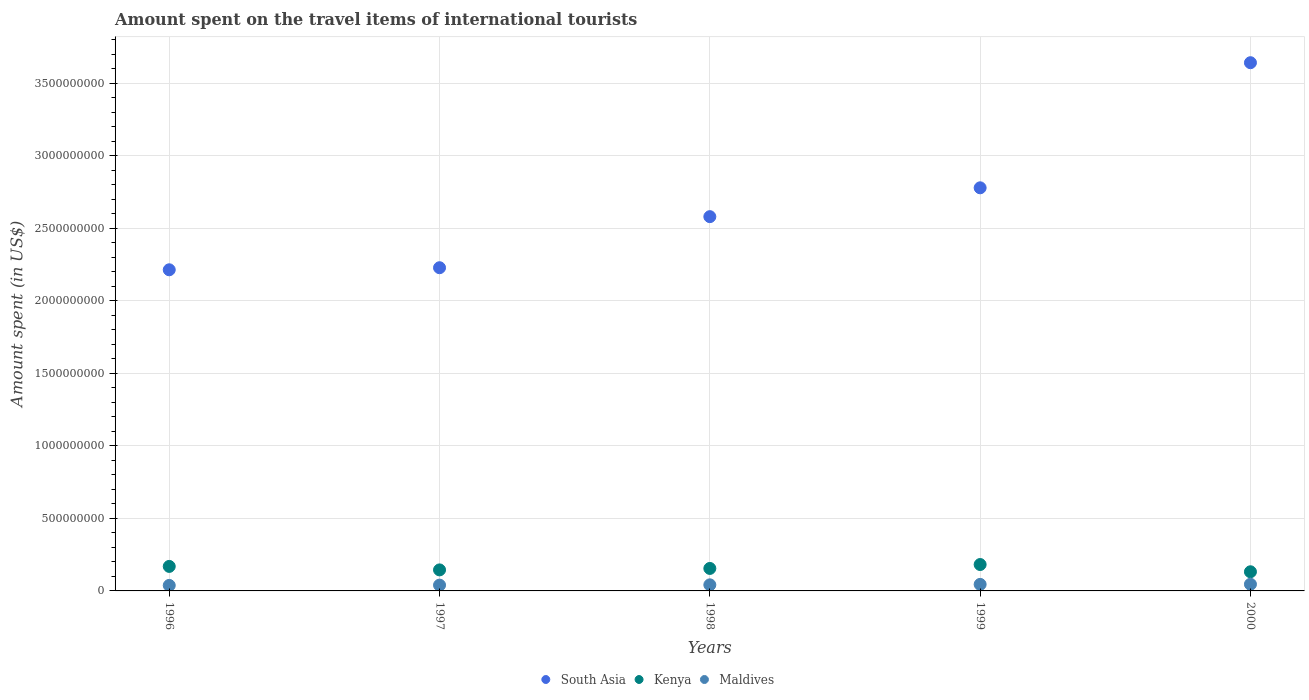What is the amount spent on the travel items of international tourists in South Asia in 1996?
Provide a short and direct response. 2.21e+09. Across all years, what is the maximum amount spent on the travel items of international tourists in Maldives?
Offer a very short reply. 4.60e+07. Across all years, what is the minimum amount spent on the travel items of international tourists in Maldives?
Keep it short and to the point. 3.80e+07. In which year was the amount spent on the travel items of international tourists in Kenya minimum?
Offer a very short reply. 2000. What is the total amount spent on the travel items of international tourists in Kenya in the graph?
Provide a short and direct response. 7.83e+08. What is the difference between the amount spent on the travel items of international tourists in Kenya in 1996 and that in 1997?
Give a very brief answer. 2.40e+07. What is the difference between the amount spent on the travel items of international tourists in South Asia in 1999 and the amount spent on the travel items of international tourists in Kenya in 1996?
Offer a very short reply. 2.61e+09. What is the average amount spent on the travel items of international tourists in Kenya per year?
Provide a short and direct response. 1.57e+08. In the year 2000, what is the difference between the amount spent on the travel items of international tourists in Maldives and amount spent on the travel items of international tourists in Kenya?
Provide a succinct answer. -8.60e+07. In how many years, is the amount spent on the travel items of international tourists in Maldives greater than 3100000000 US$?
Your answer should be very brief. 0. What is the ratio of the amount spent on the travel items of international tourists in South Asia in 1996 to that in 1999?
Your response must be concise. 0.8. Is the difference between the amount spent on the travel items of international tourists in Maldives in 1997 and 2000 greater than the difference between the amount spent on the travel items of international tourists in Kenya in 1997 and 2000?
Provide a succinct answer. No. In how many years, is the amount spent on the travel items of international tourists in Kenya greater than the average amount spent on the travel items of international tourists in Kenya taken over all years?
Offer a very short reply. 2. Is the sum of the amount spent on the travel items of international tourists in Kenya in 1996 and 2000 greater than the maximum amount spent on the travel items of international tourists in South Asia across all years?
Your response must be concise. No. Is the amount spent on the travel items of international tourists in Kenya strictly greater than the amount spent on the travel items of international tourists in Maldives over the years?
Your answer should be compact. Yes. Is the amount spent on the travel items of international tourists in Kenya strictly less than the amount spent on the travel items of international tourists in Maldives over the years?
Provide a short and direct response. No. How many dotlines are there?
Make the answer very short. 3. Are the values on the major ticks of Y-axis written in scientific E-notation?
Ensure brevity in your answer.  No. Does the graph contain any zero values?
Your response must be concise. No. Does the graph contain grids?
Give a very brief answer. Yes. How many legend labels are there?
Give a very brief answer. 3. How are the legend labels stacked?
Your answer should be very brief. Horizontal. What is the title of the graph?
Keep it short and to the point. Amount spent on the travel items of international tourists. Does "Malaysia" appear as one of the legend labels in the graph?
Offer a terse response. No. What is the label or title of the X-axis?
Your answer should be very brief. Years. What is the label or title of the Y-axis?
Your response must be concise. Amount spent (in US$). What is the Amount spent (in US$) of South Asia in 1996?
Offer a terse response. 2.21e+09. What is the Amount spent (in US$) in Kenya in 1996?
Ensure brevity in your answer.  1.69e+08. What is the Amount spent (in US$) of Maldives in 1996?
Give a very brief answer. 3.80e+07. What is the Amount spent (in US$) in South Asia in 1997?
Your answer should be compact. 2.23e+09. What is the Amount spent (in US$) of Kenya in 1997?
Your answer should be compact. 1.45e+08. What is the Amount spent (in US$) of Maldives in 1997?
Provide a succinct answer. 4.00e+07. What is the Amount spent (in US$) in South Asia in 1998?
Provide a short and direct response. 2.58e+09. What is the Amount spent (in US$) in Kenya in 1998?
Your response must be concise. 1.55e+08. What is the Amount spent (in US$) in Maldives in 1998?
Provide a succinct answer. 4.20e+07. What is the Amount spent (in US$) in South Asia in 1999?
Keep it short and to the point. 2.78e+09. What is the Amount spent (in US$) of Kenya in 1999?
Your answer should be compact. 1.82e+08. What is the Amount spent (in US$) in Maldives in 1999?
Your answer should be very brief. 4.50e+07. What is the Amount spent (in US$) of South Asia in 2000?
Your answer should be compact. 3.64e+09. What is the Amount spent (in US$) in Kenya in 2000?
Make the answer very short. 1.32e+08. What is the Amount spent (in US$) of Maldives in 2000?
Provide a short and direct response. 4.60e+07. Across all years, what is the maximum Amount spent (in US$) of South Asia?
Offer a very short reply. 3.64e+09. Across all years, what is the maximum Amount spent (in US$) in Kenya?
Provide a short and direct response. 1.82e+08. Across all years, what is the maximum Amount spent (in US$) of Maldives?
Your answer should be compact. 4.60e+07. Across all years, what is the minimum Amount spent (in US$) in South Asia?
Your answer should be very brief. 2.21e+09. Across all years, what is the minimum Amount spent (in US$) in Kenya?
Ensure brevity in your answer.  1.32e+08. Across all years, what is the minimum Amount spent (in US$) in Maldives?
Make the answer very short. 3.80e+07. What is the total Amount spent (in US$) in South Asia in the graph?
Provide a short and direct response. 1.34e+1. What is the total Amount spent (in US$) of Kenya in the graph?
Your answer should be very brief. 7.83e+08. What is the total Amount spent (in US$) of Maldives in the graph?
Your response must be concise. 2.11e+08. What is the difference between the Amount spent (in US$) of South Asia in 1996 and that in 1997?
Ensure brevity in your answer.  -1.42e+07. What is the difference between the Amount spent (in US$) in Kenya in 1996 and that in 1997?
Make the answer very short. 2.40e+07. What is the difference between the Amount spent (in US$) in Maldives in 1996 and that in 1997?
Give a very brief answer. -2.00e+06. What is the difference between the Amount spent (in US$) in South Asia in 1996 and that in 1998?
Ensure brevity in your answer.  -3.66e+08. What is the difference between the Amount spent (in US$) in Kenya in 1996 and that in 1998?
Your answer should be compact. 1.40e+07. What is the difference between the Amount spent (in US$) of Maldives in 1996 and that in 1998?
Ensure brevity in your answer.  -4.00e+06. What is the difference between the Amount spent (in US$) of South Asia in 1996 and that in 1999?
Ensure brevity in your answer.  -5.65e+08. What is the difference between the Amount spent (in US$) of Kenya in 1996 and that in 1999?
Make the answer very short. -1.30e+07. What is the difference between the Amount spent (in US$) in Maldives in 1996 and that in 1999?
Make the answer very short. -7.00e+06. What is the difference between the Amount spent (in US$) in South Asia in 1996 and that in 2000?
Keep it short and to the point. -1.43e+09. What is the difference between the Amount spent (in US$) of Kenya in 1996 and that in 2000?
Offer a terse response. 3.70e+07. What is the difference between the Amount spent (in US$) of Maldives in 1996 and that in 2000?
Provide a succinct answer. -8.00e+06. What is the difference between the Amount spent (in US$) of South Asia in 1997 and that in 1998?
Offer a terse response. -3.52e+08. What is the difference between the Amount spent (in US$) in Kenya in 1997 and that in 1998?
Keep it short and to the point. -1.00e+07. What is the difference between the Amount spent (in US$) in South Asia in 1997 and that in 1999?
Offer a terse response. -5.51e+08. What is the difference between the Amount spent (in US$) in Kenya in 1997 and that in 1999?
Your response must be concise. -3.70e+07. What is the difference between the Amount spent (in US$) of Maldives in 1997 and that in 1999?
Offer a very short reply. -5.00e+06. What is the difference between the Amount spent (in US$) of South Asia in 1997 and that in 2000?
Make the answer very short. -1.41e+09. What is the difference between the Amount spent (in US$) of Kenya in 1997 and that in 2000?
Offer a very short reply. 1.30e+07. What is the difference between the Amount spent (in US$) of Maldives in 1997 and that in 2000?
Offer a very short reply. -6.00e+06. What is the difference between the Amount spent (in US$) in South Asia in 1998 and that in 1999?
Your answer should be compact. -1.99e+08. What is the difference between the Amount spent (in US$) in Kenya in 1998 and that in 1999?
Provide a succinct answer. -2.70e+07. What is the difference between the Amount spent (in US$) of Maldives in 1998 and that in 1999?
Your response must be concise. -3.00e+06. What is the difference between the Amount spent (in US$) of South Asia in 1998 and that in 2000?
Provide a succinct answer. -1.06e+09. What is the difference between the Amount spent (in US$) in Kenya in 1998 and that in 2000?
Your response must be concise. 2.30e+07. What is the difference between the Amount spent (in US$) in Maldives in 1998 and that in 2000?
Your answer should be very brief. -4.00e+06. What is the difference between the Amount spent (in US$) in South Asia in 1999 and that in 2000?
Provide a short and direct response. -8.63e+08. What is the difference between the Amount spent (in US$) of Maldives in 1999 and that in 2000?
Provide a short and direct response. -1.00e+06. What is the difference between the Amount spent (in US$) of South Asia in 1996 and the Amount spent (in US$) of Kenya in 1997?
Your response must be concise. 2.07e+09. What is the difference between the Amount spent (in US$) in South Asia in 1996 and the Amount spent (in US$) in Maldives in 1997?
Provide a succinct answer. 2.17e+09. What is the difference between the Amount spent (in US$) in Kenya in 1996 and the Amount spent (in US$) in Maldives in 1997?
Ensure brevity in your answer.  1.29e+08. What is the difference between the Amount spent (in US$) of South Asia in 1996 and the Amount spent (in US$) of Kenya in 1998?
Give a very brief answer. 2.06e+09. What is the difference between the Amount spent (in US$) of South Asia in 1996 and the Amount spent (in US$) of Maldives in 1998?
Give a very brief answer. 2.17e+09. What is the difference between the Amount spent (in US$) in Kenya in 1996 and the Amount spent (in US$) in Maldives in 1998?
Make the answer very short. 1.27e+08. What is the difference between the Amount spent (in US$) in South Asia in 1996 and the Amount spent (in US$) in Kenya in 1999?
Your answer should be compact. 2.03e+09. What is the difference between the Amount spent (in US$) of South Asia in 1996 and the Amount spent (in US$) of Maldives in 1999?
Provide a short and direct response. 2.17e+09. What is the difference between the Amount spent (in US$) of Kenya in 1996 and the Amount spent (in US$) of Maldives in 1999?
Your answer should be compact. 1.24e+08. What is the difference between the Amount spent (in US$) of South Asia in 1996 and the Amount spent (in US$) of Kenya in 2000?
Give a very brief answer. 2.08e+09. What is the difference between the Amount spent (in US$) of South Asia in 1996 and the Amount spent (in US$) of Maldives in 2000?
Your answer should be very brief. 2.17e+09. What is the difference between the Amount spent (in US$) of Kenya in 1996 and the Amount spent (in US$) of Maldives in 2000?
Provide a succinct answer. 1.23e+08. What is the difference between the Amount spent (in US$) of South Asia in 1997 and the Amount spent (in US$) of Kenya in 1998?
Your answer should be very brief. 2.07e+09. What is the difference between the Amount spent (in US$) of South Asia in 1997 and the Amount spent (in US$) of Maldives in 1998?
Offer a very short reply. 2.19e+09. What is the difference between the Amount spent (in US$) of Kenya in 1997 and the Amount spent (in US$) of Maldives in 1998?
Provide a short and direct response. 1.03e+08. What is the difference between the Amount spent (in US$) in South Asia in 1997 and the Amount spent (in US$) in Kenya in 1999?
Ensure brevity in your answer.  2.05e+09. What is the difference between the Amount spent (in US$) of South Asia in 1997 and the Amount spent (in US$) of Maldives in 1999?
Your answer should be very brief. 2.18e+09. What is the difference between the Amount spent (in US$) of South Asia in 1997 and the Amount spent (in US$) of Kenya in 2000?
Provide a short and direct response. 2.10e+09. What is the difference between the Amount spent (in US$) of South Asia in 1997 and the Amount spent (in US$) of Maldives in 2000?
Offer a terse response. 2.18e+09. What is the difference between the Amount spent (in US$) of Kenya in 1997 and the Amount spent (in US$) of Maldives in 2000?
Provide a short and direct response. 9.90e+07. What is the difference between the Amount spent (in US$) of South Asia in 1998 and the Amount spent (in US$) of Kenya in 1999?
Provide a succinct answer. 2.40e+09. What is the difference between the Amount spent (in US$) in South Asia in 1998 and the Amount spent (in US$) in Maldives in 1999?
Your answer should be compact. 2.54e+09. What is the difference between the Amount spent (in US$) in Kenya in 1998 and the Amount spent (in US$) in Maldives in 1999?
Offer a terse response. 1.10e+08. What is the difference between the Amount spent (in US$) in South Asia in 1998 and the Amount spent (in US$) in Kenya in 2000?
Your answer should be compact. 2.45e+09. What is the difference between the Amount spent (in US$) in South Asia in 1998 and the Amount spent (in US$) in Maldives in 2000?
Your answer should be compact. 2.53e+09. What is the difference between the Amount spent (in US$) in Kenya in 1998 and the Amount spent (in US$) in Maldives in 2000?
Keep it short and to the point. 1.09e+08. What is the difference between the Amount spent (in US$) in South Asia in 1999 and the Amount spent (in US$) in Kenya in 2000?
Provide a succinct answer. 2.65e+09. What is the difference between the Amount spent (in US$) in South Asia in 1999 and the Amount spent (in US$) in Maldives in 2000?
Give a very brief answer. 2.73e+09. What is the difference between the Amount spent (in US$) in Kenya in 1999 and the Amount spent (in US$) in Maldives in 2000?
Offer a very short reply. 1.36e+08. What is the average Amount spent (in US$) of South Asia per year?
Keep it short and to the point. 2.69e+09. What is the average Amount spent (in US$) of Kenya per year?
Make the answer very short. 1.57e+08. What is the average Amount spent (in US$) in Maldives per year?
Keep it short and to the point. 4.22e+07. In the year 1996, what is the difference between the Amount spent (in US$) in South Asia and Amount spent (in US$) in Kenya?
Give a very brief answer. 2.05e+09. In the year 1996, what is the difference between the Amount spent (in US$) in South Asia and Amount spent (in US$) in Maldives?
Keep it short and to the point. 2.18e+09. In the year 1996, what is the difference between the Amount spent (in US$) in Kenya and Amount spent (in US$) in Maldives?
Offer a terse response. 1.31e+08. In the year 1997, what is the difference between the Amount spent (in US$) in South Asia and Amount spent (in US$) in Kenya?
Your response must be concise. 2.08e+09. In the year 1997, what is the difference between the Amount spent (in US$) in South Asia and Amount spent (in US$) in Maldives?
Offer a terse response. 2.19e+09. In the year 1997, what is the difference between the Amount spent (in US$) in Kenya and Amount spent (in US$) in Maldives?
Make the answer very short. 1.05e+08. In the year 1998, what is the difference between the Amount spent (in US$) of South Asia and Amount spent (in US$) of Kenya?
Your answer should be very brief. 2.43e+09. In the year 1998, what is the difference between the Amount spent (in US$) in South Asia and Amount spent (in US$) in Maldives?
Your answer should be very brief. 2.54e+09. In the year 1998, what is the difference between the Amount spent (in US$) in Kenya and Amount spent (in US$) in Maldives?
Offer a terse response. 1.13e+08. In the year 1999, what is the difference between the Amount spent (in US$) in South Asia and Amount spent (in US$) in Kenya?
Provide a short and direct response. 2.60e+09. In the year 1999, what is the difference between the Amount spent (in US$) in South Asia and Amount spent (in US$) in Maldives?
Your answer should be very brief. 2.73e+09. In the year 1999, what is the difference between the Amount spent (in US$) of Kenya and Amount spent (in US$) of Maldives?
Offer a very short reply. 1.37e+08. In the year 2000, what is the difference between the Amount spent (in US$) of South Asia and Amount spent (in US$) of Kenya?
Ensure brevity in your answer.  3.51e+09. In the year 2000, what is the difference between the Amount spent (in US$) of South Asia and Amount spent (in US$) of Maldives?
Your answer should be very brief. 3.60e+09. In the year 2000, what is the difference between the Amount spent (in US$) of Kenya and Amount spent (in US$) of Maldives?
Make the answer very short. 8.60e+07. What is the ratio of the Amount spent (in US$) in South Asia in 1996 to that in 1997?
Ensure brevity in your answer.  0.99. What is the ratio of the Amount spent (in US$) of Kenya in 1996 to that in 1997?
Give a very brief answer. 1.17. What is the ratio of the Amount spent (in US$) of Maldives in 1996 to that in 1997?
Your answer should be compact. 0.95. What is the ratio of the Amount spent (in US$) in South Asia in 1996 to that in 1998?
Provide a succinct answer. 0.86. What is the ratio of the Amount spent (in US$) of Kenya in 1996 to that in 1998?
Offer a terse response. 1.09. What is the ratio of the Amount spent (in US$) in Maldives in 1996 to that in 1998?
Give a very brief answer. 0.9. What is the ratio of the Amount spent (in US$) of South Asia in 1996 to that in 1999?
Offer a terse response. 0.8. What is the ratio of the Amount spent (in US$) in Kenya in 1996 to that in 1999?
Ensure brevity in your answer.  0.93. What is the ratio of the Amount spent (in US$) in Maldives in 1996 to that in 1999?
Your answer should be very brief. 0.84. What is the ratio of the Amount spent (in US$) in South Asia in 1996 to that in 2000?
Your response must be concise. 0.61. What is the ratio of the Amount spent (in US$) of Kenya in 1996 to that in 2000?
Provide a succinct answer. 1.28. What is the ratio of the Amount spent (in US$) in Maldives in 1996 to that in 2000?
Your response must be concise. 0.83. What is the ratio of the Amount spent (in US$) in South Asia in 1997 to that in 1998?
Offer a terse response. 0.86. What is the ratio of the Amount spent (in US$) in Kenya in 1997 to that in 1998?
Ensure brevity in your answer.  0.94. What is the ratio of the Amount spent (in US$) of Maldives in 1997 to that in 1998?
Provide a succinct answer. 0.95. What is the ratio of the Amount spent (in US$) of South Asia in 1997 to that in 1999?
Your answer should be very brief. 0.8. What is the ratio of the Amount spent (in US$) of Kenya in 1997 to that in 1999?
Give a very brief answer. 0.8. What is the ratio of the Amount spent (in US$) of South Asia in 1997 to that in 2000?
Your answer should be very brief. 0.61. What is the ratio of the Amount spent (in US$) of Kenya in 1997 to that in 2000?
Provide a succinct answer. 1.1. What is the ratio of the Amount spent (in US$) in Maldives in 1997 to that in 2000?
Ensure brevity in your answer.  0.87. What is the ratio of the Amount spent (in US$) of South Asia in 1998 to that in 1999?
Offer a very short reply. 0.93. What is the ratio of the Amount spent (in US$) in Kenya in 1998 to that in 1999?
Offer a terse response. 0.85. What is the ratio of the Amount spent (in US$) of Maldives in 1998 to that in 1999?
Provide a short and direct response. 0.93. What is the ratio of the Amount spent (in US$) in South Asia in 1998 to that in 2000?
Your answer should be compact. 0.71. What is the ratio of the Amount spent (in US$) in Kenya in 1998 to that in 2000?
Your answer should be very brief. 1.17. What is the ratio of the Amount spent (in US$) in Maldives in 1998 to that in 2000?
Keep it short and to the point. 0.91. What is the ratio of the Amount spent (in US$) in South Asia in 1999 to that in 2000?
Your answer should be compact. 0.76. What is the ratio of the Amount spent (in US$) in Kenya in 1999 to that in 2000?
Provide a short and direct response. 1.38. What is the ratio of the Amount spent (in US$) in Maldives in 1999 to that in 2000?
Provide a short and direct response. 0.98. What is the difference between the highest and the second highest Amount spent (in US$) in South Asia?
Give a very brief answer. 8.63e+08. What is the difference between the highest and the second highest Amount spent (in US$) in Kenya?
Provide a short and direct response. 1.30e+07. What is the difference between the highest and the lowest Amount spent (in US$) of South Asia?
Your answer should be very brief. 1.43e+09. 